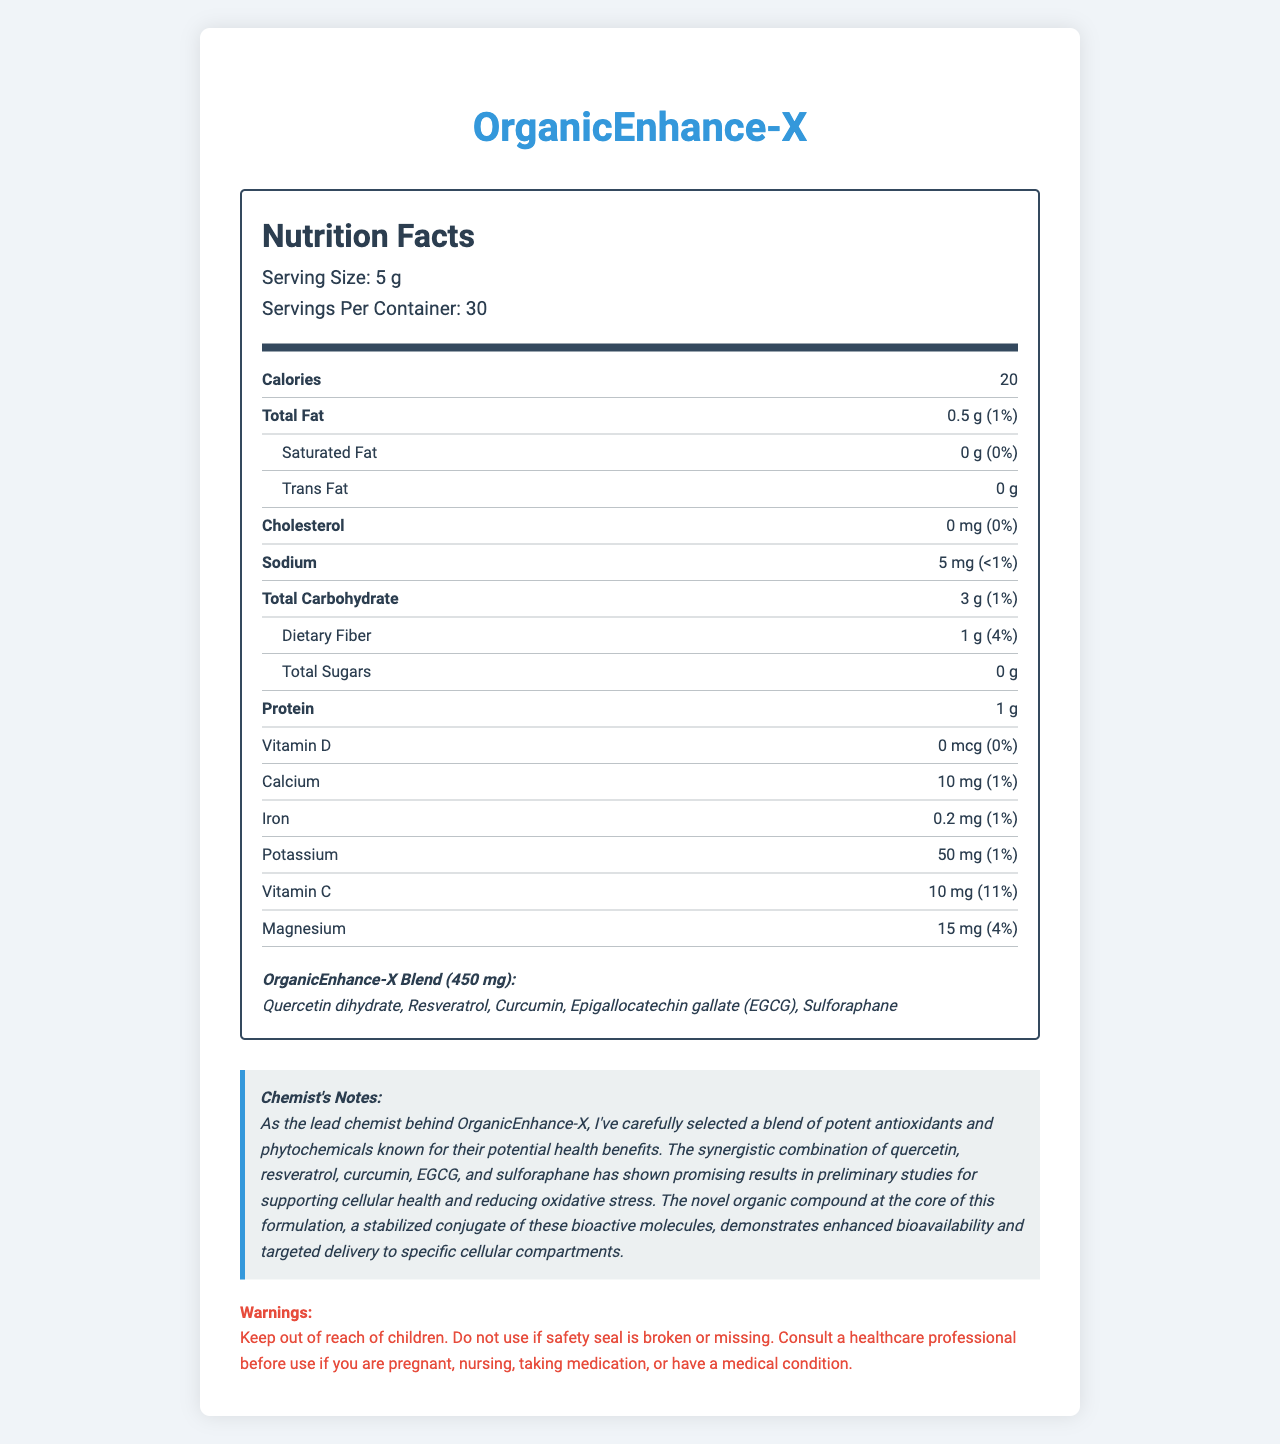What is the serving size of OrganicEnhance-X? The serving size is mentioned at the beginning in the serving information section as 5 g.
Answer: 5 g How many servings are there per container of OrganicEnhance-X? The number of servings per container is provided in the serving information section as 30.
Answer: 30 What are the main bioactive components in the OrganicEnhance-X proprietary blend? These components are listed under the proprietary blend section of the document.
Answer: Quercetin dihydrate, Resveratrol, Curcumin, Epigallocatechin gallate (EGCG), Sulforaphane What is the percentage of Daily Value for dietary fiber in one serving? The percentage of Daily Value for dietary fiber is listed as 4% in the nutrient row for dietary fiber.
Answer: 4% How much sodium is there in a serving of OrganicEnhance-X? The amount of sodium per serving is provided in the nutrient row for sodium as 5 mg.
Answer: 5 mg Which of the following nutrients has the highest daily value percentage? A. Calcium B. Vitamin D C. Magnesium D. Vitamin C Vitamin C has a daily value of 11%, which is the highest among the listed options.
Answer: D How many grams of protein are there in a serving? A. 2 g B. 1 g C. 3 g D. 5 g The amount of protein per serving is listed as 1 g.
Answer: B True or False: Organic rice flour is one of the main ingredients in the proprietary blend. Organic rice flour is listed under other ingredients, not the proprietary blend.
Answer: False Can you name any allergens contained in OrganicEnhance-X? The allergen information states that the product contains no known allergens.
Answer: Contains no known allergens How should you store OrganicEnhance-X? The storage instructions indicate to store the product in a cool, dry place away from direct sunlight.
Answer: Store in a cool, dry place away from direct sunlight. Does OrganicEnhance-X contain any cholesterol? The cholesterol content is listed as 0 mg with a daily value of 0%.
Answer: No Summarize the main idea of the Nutrition Facts Label for OrganicEnhance-X. The label contains comprehensive information about the nutritional content, composition, and usage instructions for OrganicEnhance-X, emphasizing its health benefits and safe usage instructions.
Answer: The Nutrition Facts Label provides detailed nutritional information for OrganicEnhance-X, an organic compound with potential health benefits. It includes details on serving size, number of servings per container, caloric content, and the amount and daily value percentage of various nutrients. The proprietary blend includes bioactive molecules like quercetin, resveratrol, curcumin, EGCG, and sulforaphane, which are noted for their potential health benefits. Additional information is provided regarding other ingredients, storage instructions, manufacturer details, and warnings. What is the unique stabilized conjugate mentioned in the Chemist's Notes? The document mentions that the product contains a stabilized conjugate of bioactive molecules, but it does not provide the specific details or name of this stabilized conjugate.
Answer: Cannot be determined 